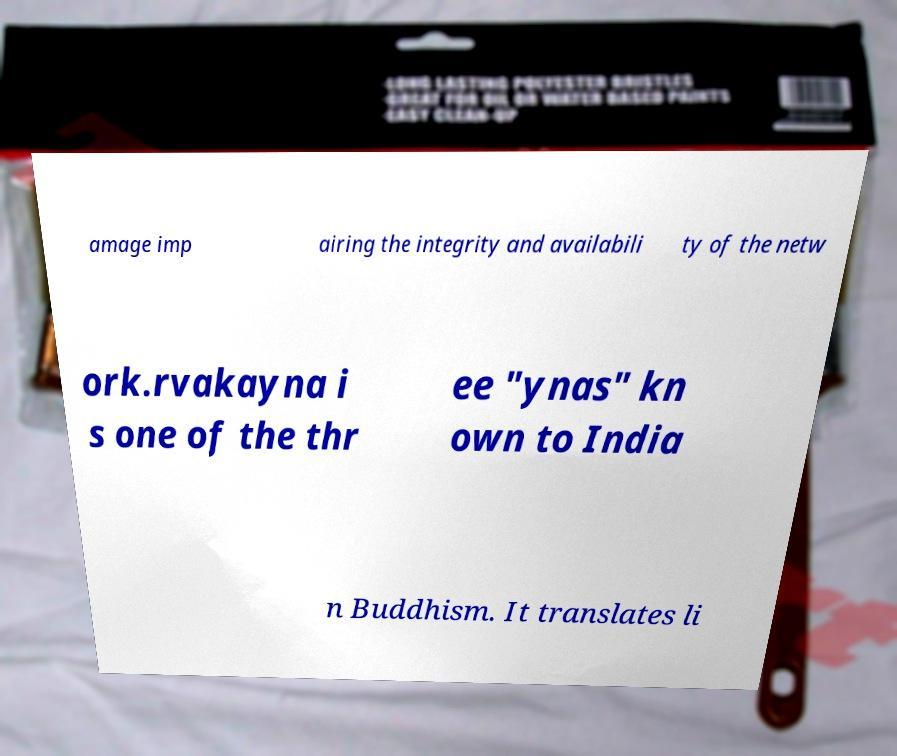Please identify and transcribe the text found in this image. amage imp airing the integrity and availabili ty of the netw ork.rvakayna i s one of the thr ee "ynas" kn own to India n Buddhism. It translates li 